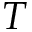Convert formula to latex. <formula><loc_0><loc_0><loc_500><loc_500>T</formula> 